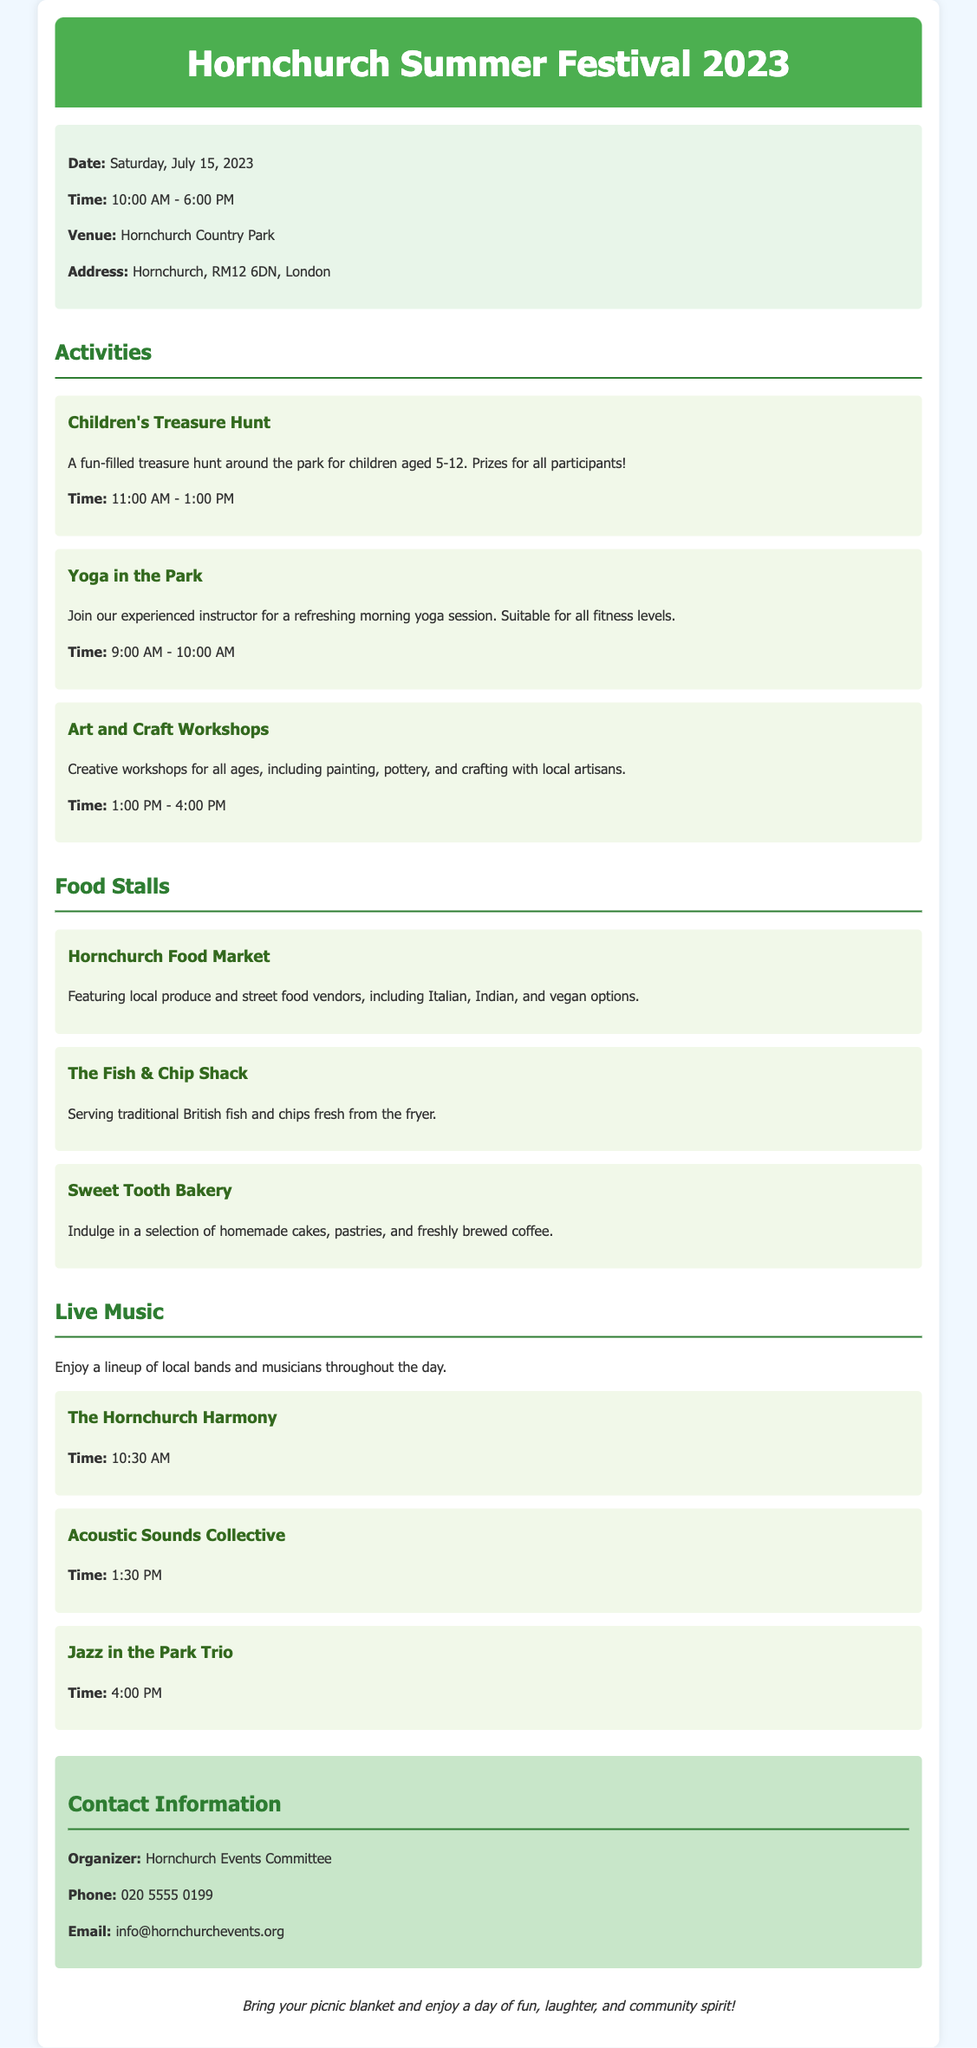What is the date of the festival? The date of the festival is explicitly stated in the document as Saturday, July 15, 2023.
Answer: Saturday, July 15, 2023 What time does the festival start? The starting time of the festival is mentioned under the event details, which is 10:00 AM.
Answer: 10:00 AM Where is the Hornchurch Summer Festival held? The venue for the Hornchurch Summer Festival is specified in the document as Hornchurch Country Park.
Answer: Hornchurch Country Park What activity is for children aged 5-12? The document mentions a specific activity for that age group, which is the Children's Treasure Hunt.
Answer: Children's Treasure Hunt How many food stalls are listed? The document lists a total of three food stalls under the food section.
Answer: Three What time does the Acoustic Sounds Collective perform? The performance time for Acoustic Sounds Collective is stated as 1:30 PM in the live music section.
Answer: 1:30 PM Who is the organizer of the event? The organizer's name is given in the contact information as Hornchurch Events Committee.
Answer: Hornchurch Events Committee What is the additional note mentioned at the end of the document? The document includes an additional note encouraging attendees to bring picnic blankets for a day of enjoyment.
Answer: Bring your picnic blanket and enjoy a day of fun, laughter, and community spirit! 